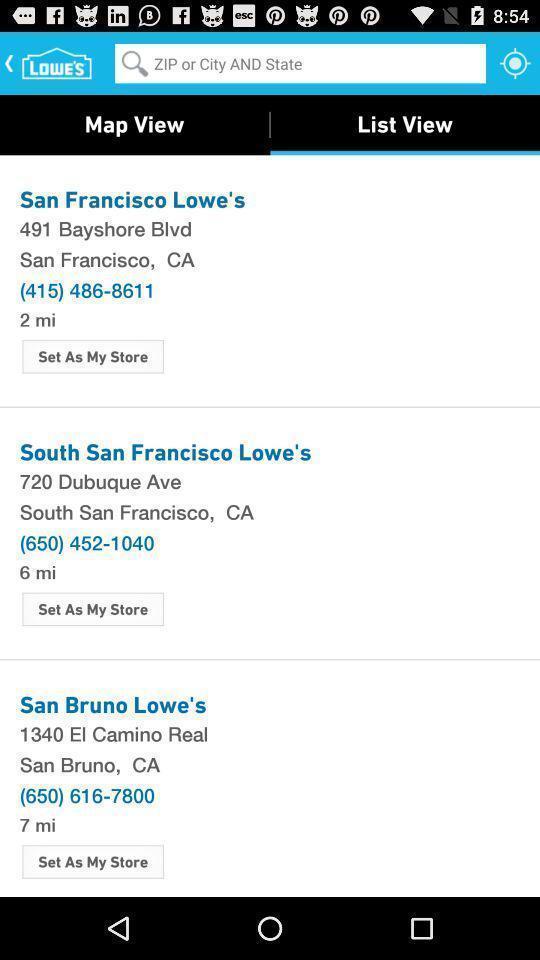Tell me about the visual elements in this screen capture. Screen displaying the list of locations. 